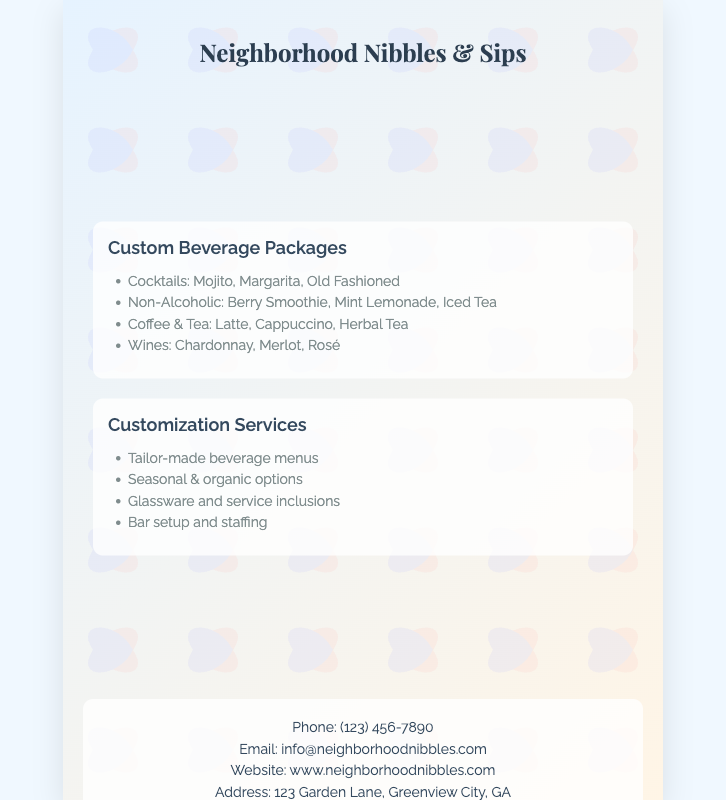What is the name of the catering service? The name of the catering service is displayed prominently at the top of the document.
Answer: Neighborhood Nibbles & Sips What beverages are included in the cocktails section? The cocktails section lists specific beverages available, which are shown in the document.
Answer: Mojito, Margarita, Old Fashioned Which non-alcoholic beverage is listed? One of the non-alcoholic beverage options is specifically mentioned in the list provided in the document.
Answer: Berry Smoothie How many customization services are offered? The document lists the customization services, and the total number can be counted from the bulleted list.
Answer: Four What types of wines are available? The document explicitly lists the types of wines that can be offered through the catering service.
Answer: Chardonnay, Merlot, Rosé What is the contact phone number? The phone number for contact is provided in the contact information section of the document.
Answer: (123) 456-7890 What kind of options are mentioned for customization? The document mentions specific customization options available for the beverage packages which can be read in the list.
Answer: Seasonal & organic options What is the address of the catering service? The address is clearly stated in the contact section of the document.
Answer: 123 Garden Lane, Greenview City, GA 